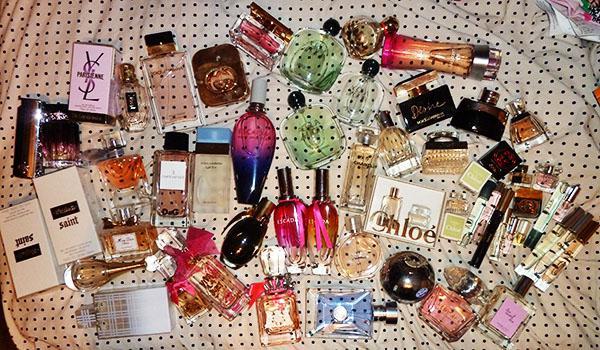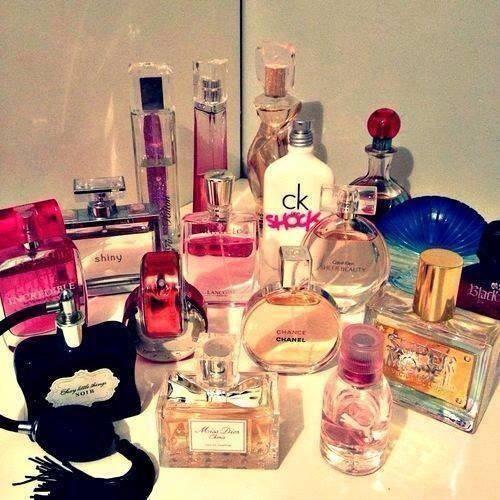The first image is the image on the left, the second image is the image on the right. For the images displayed, is the sentence "The collection of fragrance bottles on the right includes a squat round black bottle with a pink tube and bulb attached." factually correct? Answer yes or no. No. The first image is the image on the left, the second image is the image on the right. For the images displayed, is the sentence "The image on the left boasts less than ten items." factually correct? Answer yes or no. No. 